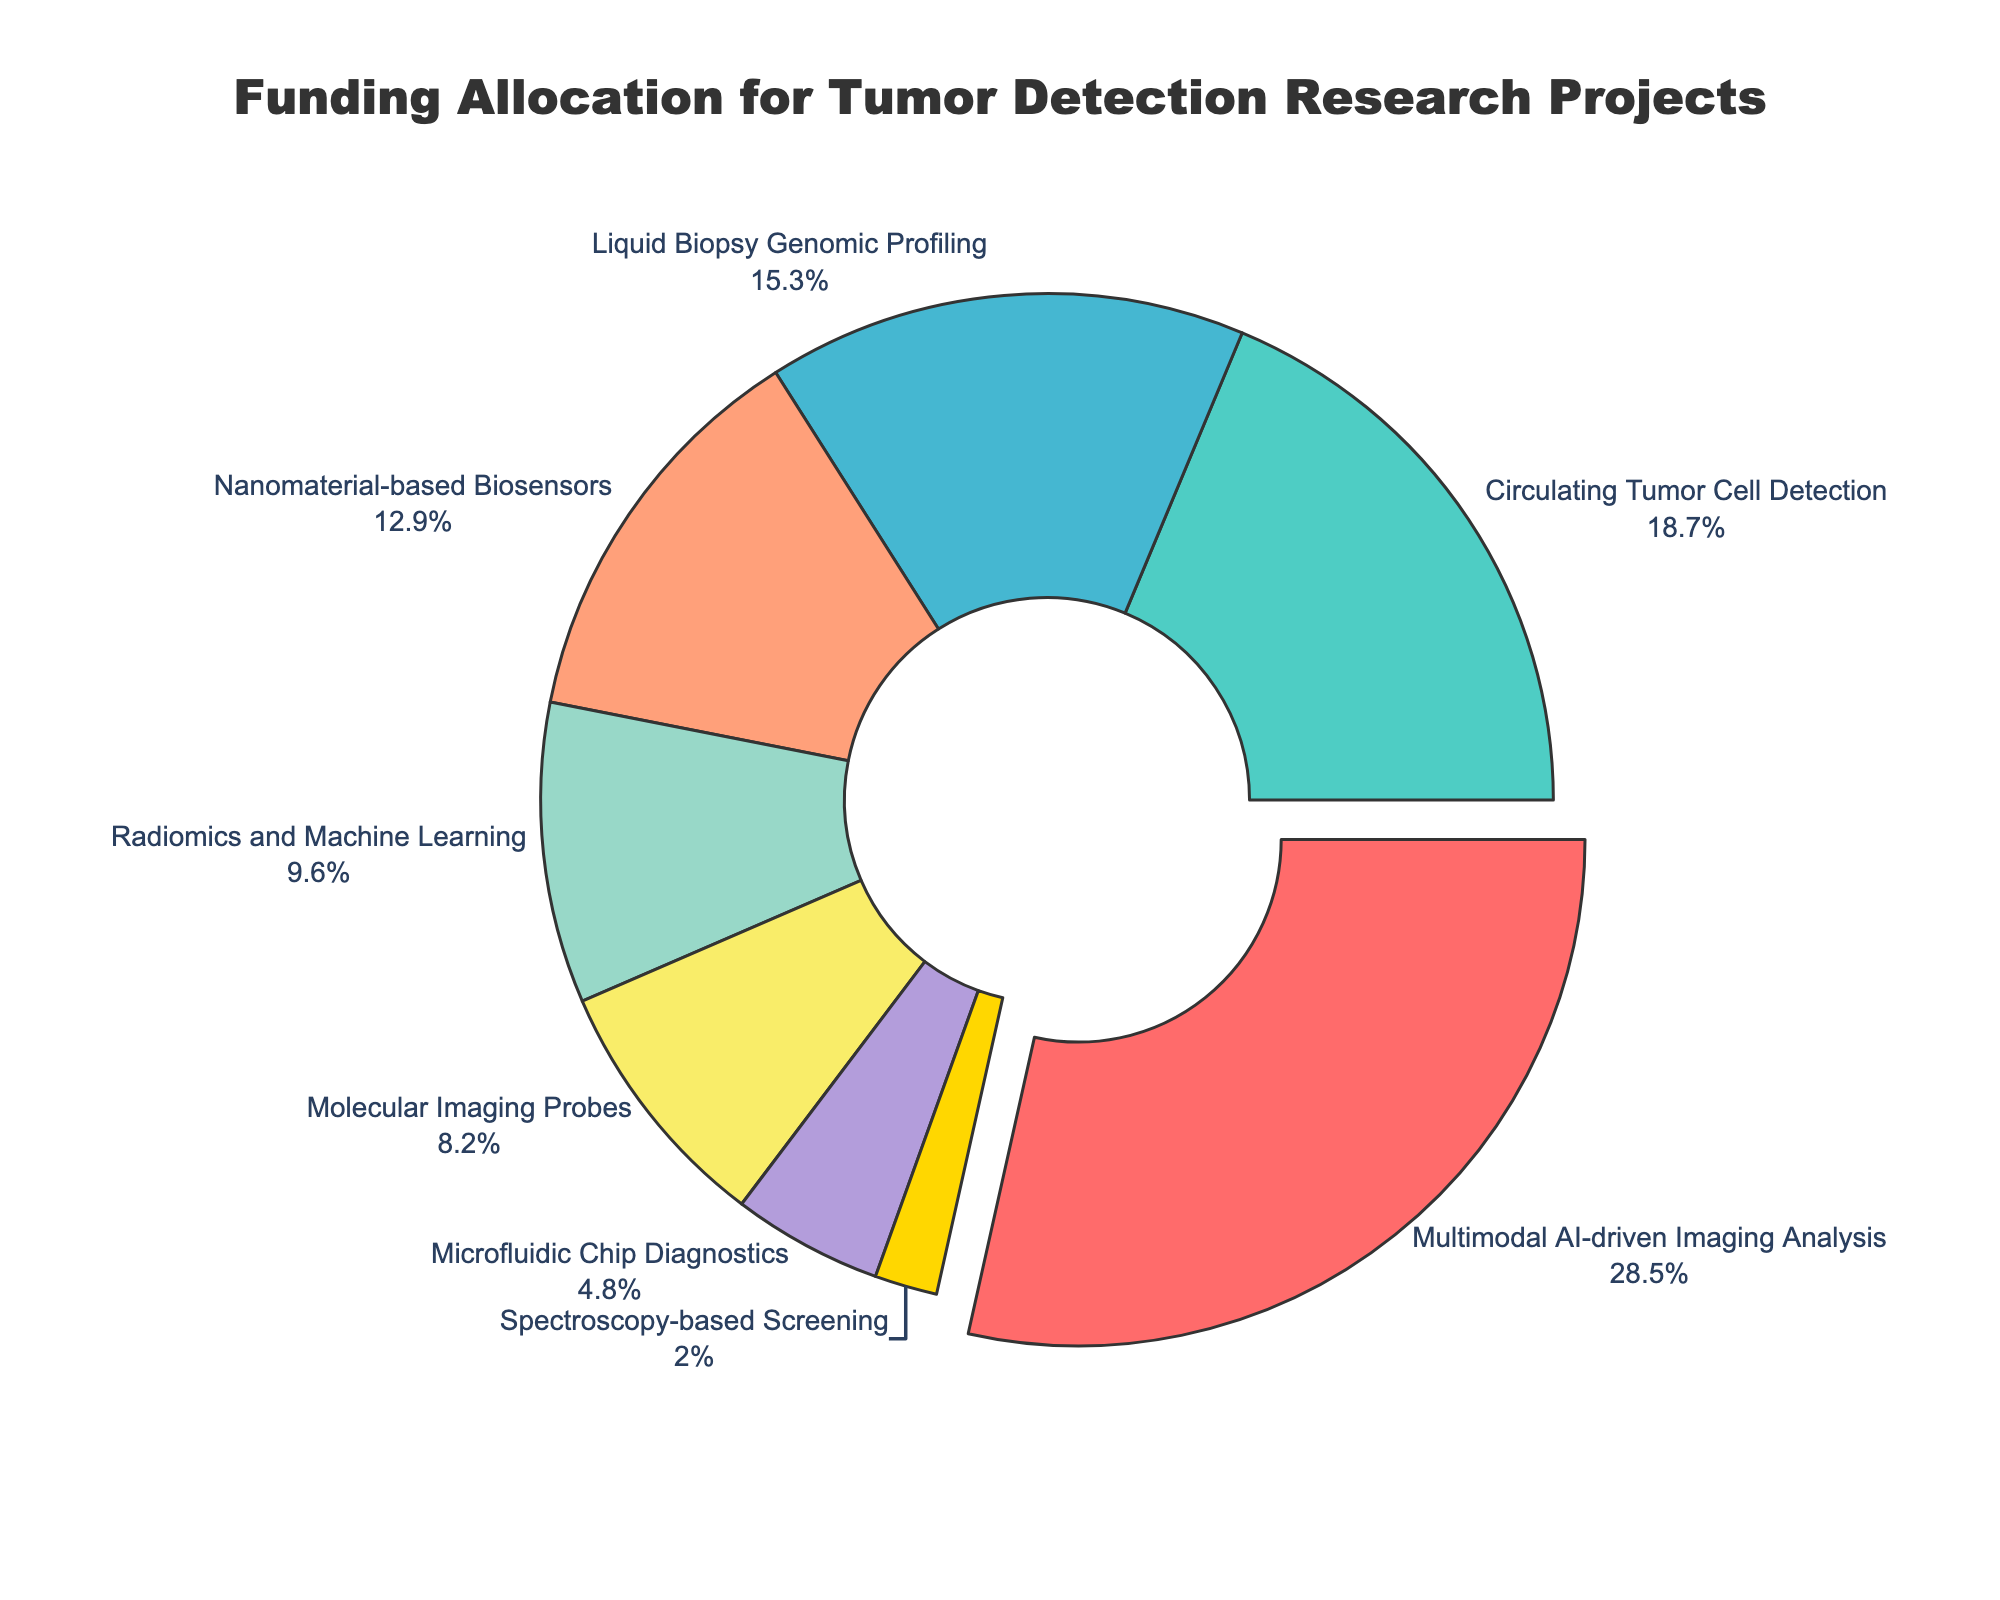Which research project received the highest funding allocation? The research project labeled "Multimodal AI-driven Imaging Analysis" shows the largest sector pulled slightly outward, indicating it received the highest funding of 28.5%.
Answer: Multimodal AI-driven Imaging Analysis What percentage of funding was allocated to "Liquid Biopsy Genomic Profiling" and "Nanomaterial-based Biosensors" combined? The funding percentages for "Liquid Biopsy Genomic Profiling" and "Nanomaterial-based Biosensors" are 15.3% and 12.9%, respectively. Adding them gives 15.3% + 12.9% = 28.2%.
Answer: 28.2% Which research project received less funding: "Radiomics and Machine Learning" or "Microfluidic Chip Diagnostics"? The funding allocation for "Radiomics and Machine Learning" is 9.6% and for "Microfluidic Chip Diagnostics" is 4.8%. Since 9.6% > 4.8%, "Microfluidic Chip Diagnostics" received less funding.
Answer: Microfluidic Chip Diagnostics What is the total percentage of funding allocated to projects receiving less than 10% funding each? Adding the funding percentages for "Radiomics and Machine Learning" (9.6%), "Molecular Imaging Probes" (8.2%), "Microfluidic Chip Diagnostics" (4.8%), and "Spectroscopy-based Screening" (2.0%) gives 9.6% + 8.2% + 4.8% + 2.0% = 24.6%.
Answer: 24.6% Is "Circulating Tumor Cell Detection" funding more or less than twice the funding for "Spectroscopy-based Screening"? The funding for "Circulating Tumor Cell Detection" is 18.7%, and for "Spectroscopy-based Screening" it is 2.0%. Twice the funding for "Spectroscopy-based Screening" is 2 * 2.0% = 4.0%. Since 18.7% > 4.0%, "Circulating Tumor Cell Detection" funding is more than twice that for "Spectroscopy-based Screening".
Answer: More What is the difference in funding allocation between "Multimodal AI-driven Imaging Analysis" and "Liquid Biopsy Genomic Profiling"? The funding allocation for "Multimodal AI-driven Imaging Analysis" is 28.5% and for "Liquid Biopsy Genomic Profiling" it is 15.3%. The difference is 28.5% - 15.3% = 13.2%.
Answer: 13.2% Which research project received the lowest funding allocation and what percentage was allocated to it? The smallest sector in the pie chart is labeled "Spectroscopy-based Screening," indicating it received the lowest funding allocation of 2.0%.
Answer: Spectroscopy-based Screening, 2.0% What is the average funding allocation for all research projects listed? Summing the funding percentages gives 28.5% + 18.7% + 15.3% + 12.9% + 9.6% + 8.2% + 4.8% + 2.0% = 100%. Since there are 8 projects, the average funding allocation is 100% / 8 = 12.5%.
Answer: 12.5% Is the sum of funding allocations for "Molecular Imaging Probes" and "Microfluidic Chip Diagnostics" greater than that of "Circulating Tumor Cell Detection"? The allocations for "Molecular Imaging Probes" and "Microfluidic Chip Diagnostics" are 8.2% and 4.8%, respectively. Summing them gives 8.2% + 4.8% = 13.0%. Since "Circulating Tumor Cell Detection" received 18.7%, 13.0% < 18.7%, so the sum is not greater.
Answer: No Which research projects have funding allocations that are greater than 10% but less than 20%? The projects with funding allocations above 10% and below 20% are "Circulating Tumor Cell Detection" with 18.7% and "Liquid Biopsy Genomic Profiling" with 15.3%.
Answer: Circulating Tumor Cell Detection, Liquid Biopsy Genomic Profiling 